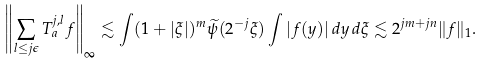<formula> <loc_0><loc_0><loc_500><loc_500>\left \| \sum _ { l \leq j \epsilon } T _ { a } ^ { j , l } f \right \| _ { \infty } \lesssim \int ( 1 + | \xi | ) ^ { m } \widetilde { \psi } ( 2 ^ { - j } \xi ) \int | f ( y ) | \, d y \, d \xi \lesssim 2 ^ { j m + j n } \| f \| _ { 1 } .</formula> 